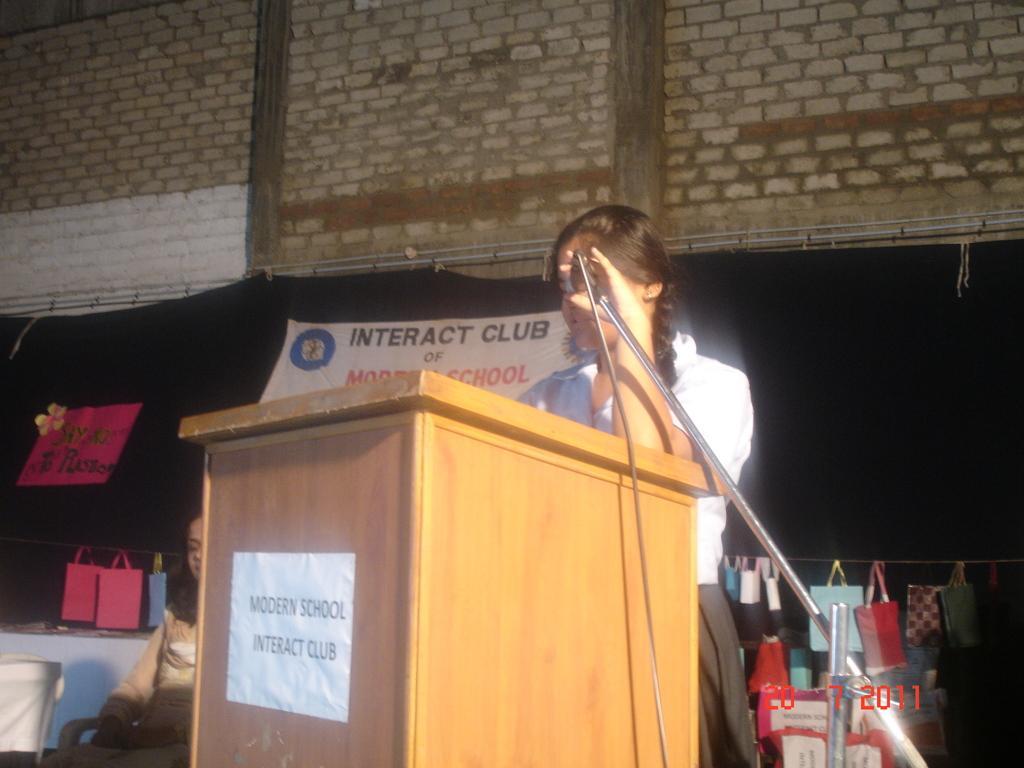In one or two sentences, can you explain what this image depicts? In the center of the image there is a lady standing and holding mic in her hand. There is a podium before her. In the background there are bags and a brick wall. 